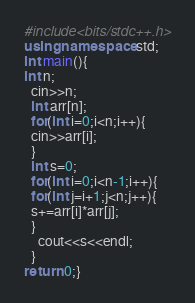<code> <loc_0><loc_0><loc_500><loc_500><_C++_>#include<bits/stdc++.h>
using namespace std;
int main(){
int n;
  cin>>n;
  int arr[n];
  for(int i=0;i<n;i++){
  cin>>arr[i];
  }
  int s=0;
  for(int i=0;i<n-1;i++){
  for(int j=i+1;j<n;j++){
  s+=arr[i]*arr[j];
  }
    cout<<s<<endl;
  }
return 0;}</code> 